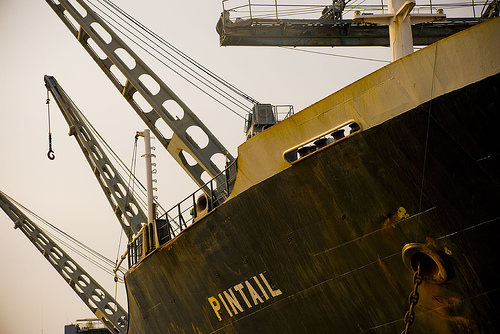<image>
Is there a hook to the right of the ship? No. The hook is not to the right of the ship. The horizontal positioning shows a different relationship. 